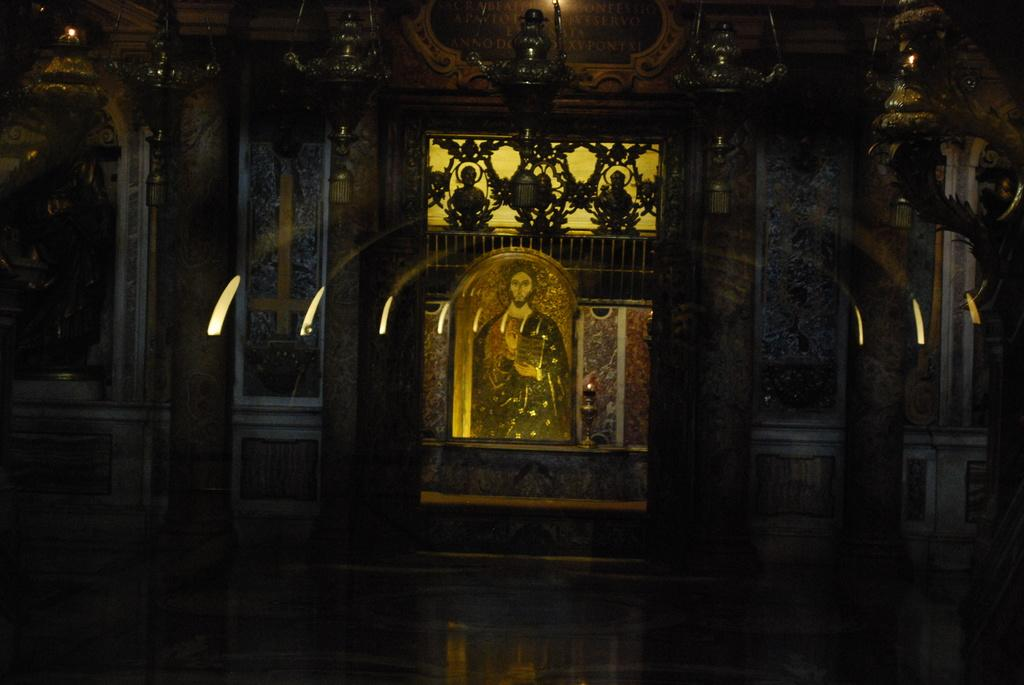What can be seen in the foreground of the image? In the foreground of the image, there are lights, pillars, and a wall. What type of structure is depicted in the image? It appears to be a framed structure in the image. What is present at the top of the image? There are lanterns at the top of the image. Can you describe the background of the image? In the background of the image, there is a lantern. How do the pigs act in the image? There are no pigs present in the image. What type of cable is used to connect the lanterns in the image? There is no mention of cables connecting the lanterns in the image. 